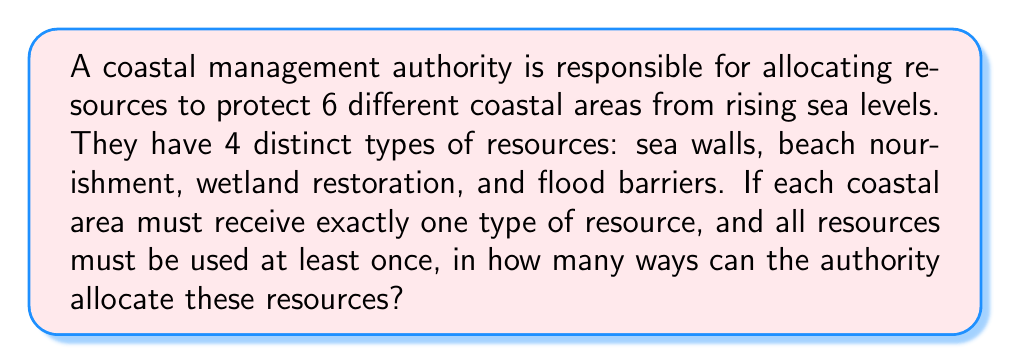Help me with this question. Let's approach this step-by-step:

1) This is a permutation problem with some constraints. We need to distribute 4 types of resources among 6 coastal areas.

2) The key constraint is that all 4 resources must be used at least once. This means we need to first allocate 4 resources to 4 different areas, and then allocate the remaining 2 resources.

3) For the first 4 allocations:
   - We have 6 choices for the first resource
   - 5 choices for the second
   - 4 choices for the third
   - 3 choices for the fourth
   This can be done in $6 \times 5 \times 4 \times 3 = 360$ ways

4) For the remaining 2 allocations:
   - We have 4 choices for each, as all 4 resources are available
   This can be done in $4 \times 4 = 16$ ways

5) By the multiplication principle, the total number of ways to allocate the resources is:

   $$ 360 \times 16 = 5,760 $$

Therefore, there are 5,760 ways to allocate the resources.
Answer: 5,760 